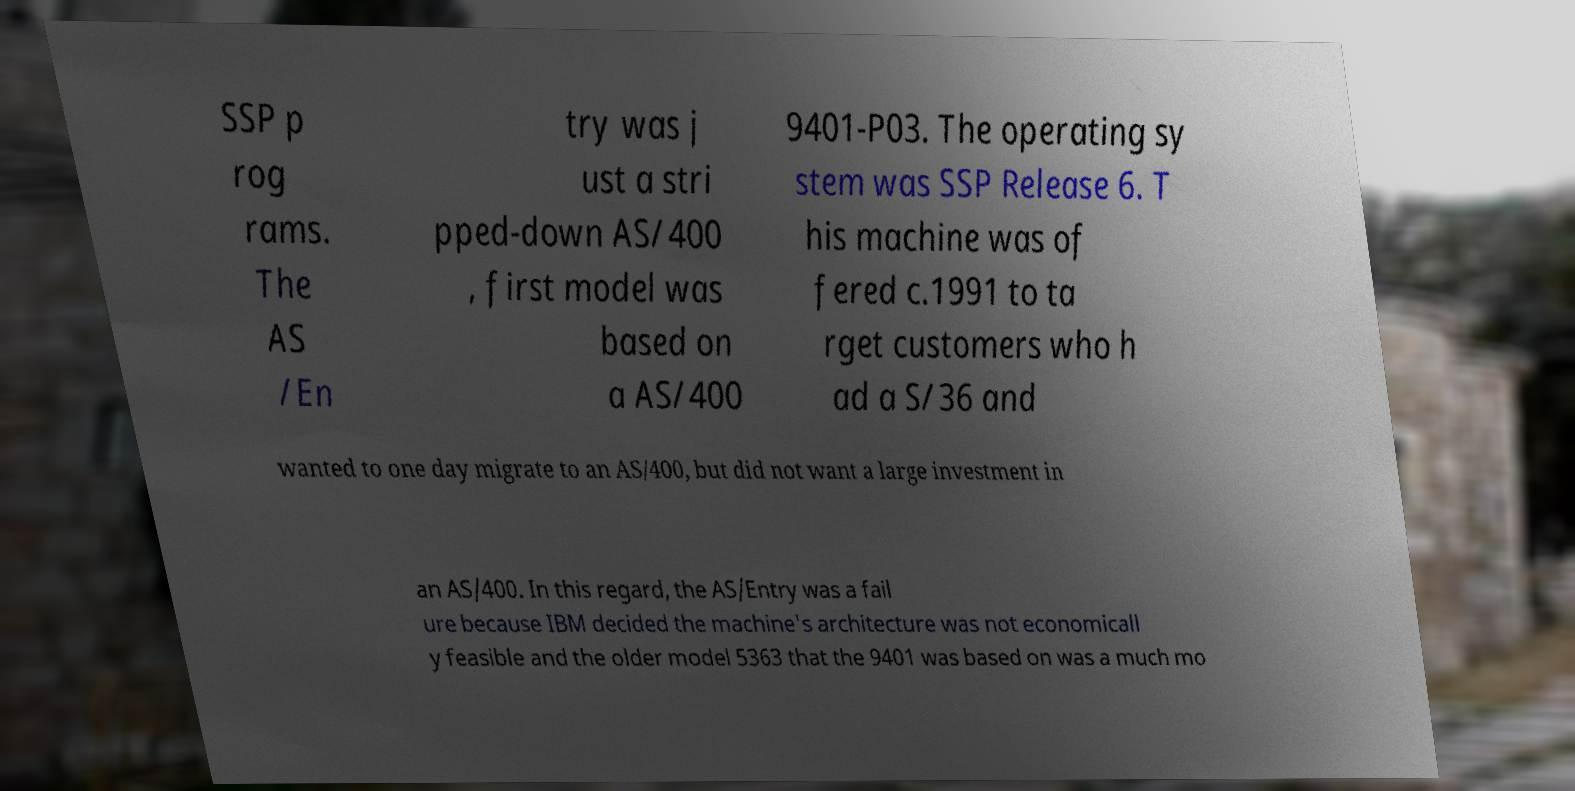Can you accurately transcribe the text from the provided image for me? SSP p rog rams. The AS /En try was j ust a stri pped-down AS/400 , first model was based on a AS/400 9401-P03. The operating sy stem was SSP Release 6. T his machine was of fered c.1991 to ta rget customers who h ad a S/36 and wanted to one day migrate to an AS/400, but did not want a large investment in an AS/400. In this regard, the AS/Entry was a fail ure because IBM decided the machine's architecture was not economicall y feasible and the older model 5363 that the 9401 was based on was a much mo 